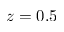Convert formula to latex. <formula><loc_0><loc_0><loc_500><loc_500>z = 0 . 5</formula> 